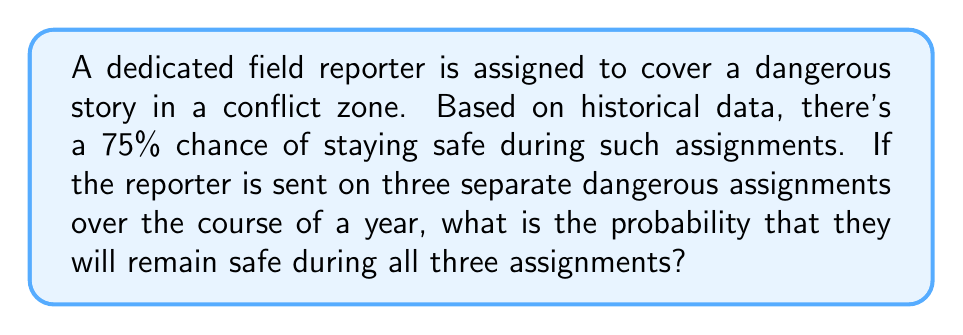Provide a solution to this math problem. To solve this problem, we need to use the concept of independent events and probability multiplication.

1. Let's define the probability of staying safe on a single assignment:
   $P(\text{safe}) = 0.75$ or $75\%$

2. We want to find the probability of staying safe on all three assignments. This means the reporter needs to be safe on the first AND second AND third assignment.

3. Since these are independent events (the outcome of one doesn't affect the others), we multiply the probabilities:

   $P(\text{safe on all 3}) = P(\text{safe on 1st}) \times P(\text{safe on 2nd}) \times P(\text{safe on 3rd})$

4. Substituting the known probability:

   $P(\text{safe on all 3}) = 0.75 \times 0.75 \times 0.75$

5. Calculating:

   $P(\text{safe on all 3}) = 0.75^3 = 0.421875$

6. Converting to a percentage:

   $0.421875 \times 100\% = 42.1875\%$

This means there's approximately a 42.19% chance that the reporter will remain safe during all three dangerous assignments.
Answer: The probability that the reporter will remain safe during all three dangerous assignments is $0.421875$ or $42.1875\%$. 